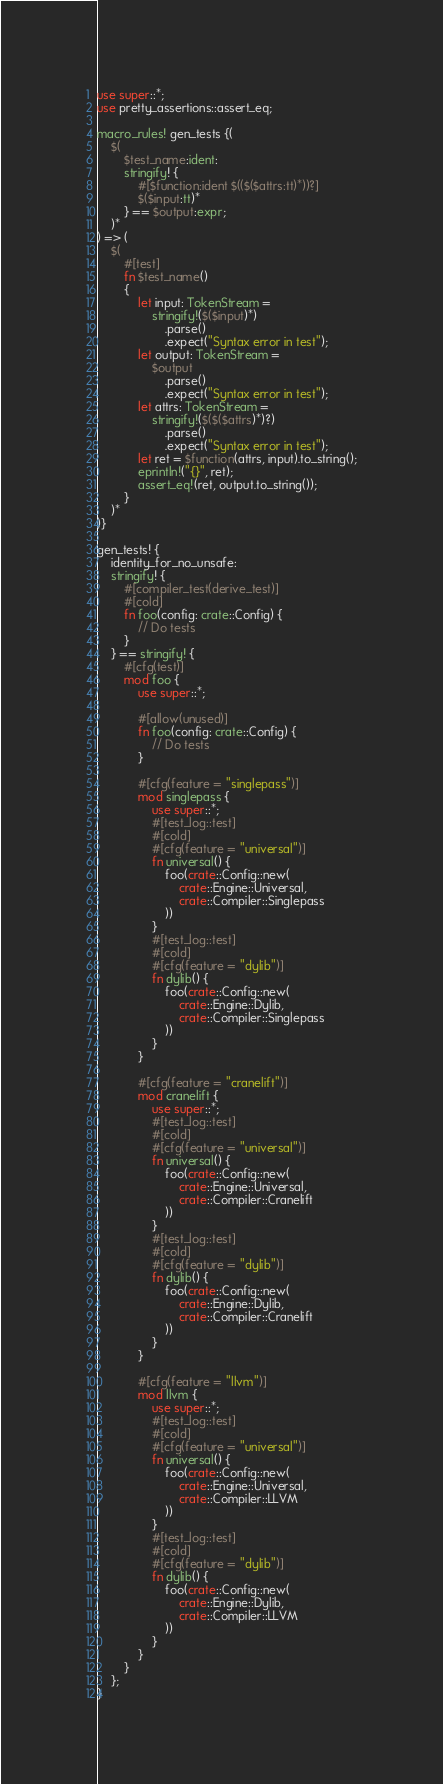<code> <loc_0><loc_0><loc_500><loc_500><_Rust_>use super::*;
use pretty_assertions::assert_eq;

macro_rules! gen_tests {(
    $(
        $test_name:ident:
        stringify! {
            #[$function:ident $(($($attrs:tt)*))?]
            $($input:tt)*
        } == $output:expr;
    )*
) => (
    $(
        #[test]
        fn $test_name()
        {
            let input: TokenStream =
                stringify!($($input)*)
                    .parse()
                    .expect("Syntax error in test");
            let output: TokenStream =
                $output
                    .parse()
                    .expect("Syntax error in test");
            let attrs: TokenStream =
                stringify!($($($attrs)*)?)
                    .parse()
                    .expect("Syntax error in test");
            let ret = $function(attrs, input).to_string();
            eprintln!("{}", ret);
            assert_eq!(ret, output.to_string());
        }
    )*
)}

gen_tests! {
    identity_for_no_unsafe:
    stringify! {
        #[compiler_test(derive_test)]
        #[cold]
        fn foo(config: crate::Config) {
            // Do tests
        }
    } == stringify! {
        #[cfg(test)]
        mod foo {
            use super::*;

            #[allow(unused)]
            fn foo(config: crate::Config) {
                // Do tests
            }

            #[cfg(feature = "singlepass")]
            mod singlepass {
                use super::*;
                #[test_log::test]
                #[cold]
                #[cfg(feature = "universal")]
                fn universal() {
                    foo(crate::Config::new(
                        crate::Engine::Universal,
                        crate::Compiler::Singlepass
                    ))
                }
                #[test_log::test]
                #[cold]
                #[cfg(feature = "dylib")]
                fn dylib() {
                    foo(crate::Config::new(
                        crate::Engine::Dylib,
                        crate::Compiler::Singlepass
                    ))
                }
            }

            #[cfg(feature = "cranelift")]
            mod cranelift {
                use super::*;
                #[test_log::test]
                #[cold]
                #[cfg(feature = "universal")]
                fn universal() {
                    foo(crate::Config::new(
                        crate::Engine::Universal,
                        crate::Compiler::Cranelift
                    ))
                }
                #[test_log::test]
                #[cold]
                #[cfg(feature = "dylib")]
                fn dylib() {
                    foo(crate::Config::new(
                        crate::Engine::Dylib,
                        crate::Compiler::Cranelift
                    ))
                }
            }

            #[cfg(feature = "llvm")]
            mod llvm {
                use super::*;
                #[test_log::test]
                #[cold]
                #[cfg(feature = "universal")]
                fn universal() {
                    foo(crate::Config::new(
                        crate::Engine::Universal,
                        crate::Compiler::LLVM
                    ))
                }
                #[test_log::test]
                #[cold]
                #[cfg(feature = "dylib")]
                fn dylib() {
                    foo(crate::Config::new(
                        crate::Engine::Dylib,
                        crate::Compiler::LLVM
                    ))
                }
            }
        }
    };
}
</code> 